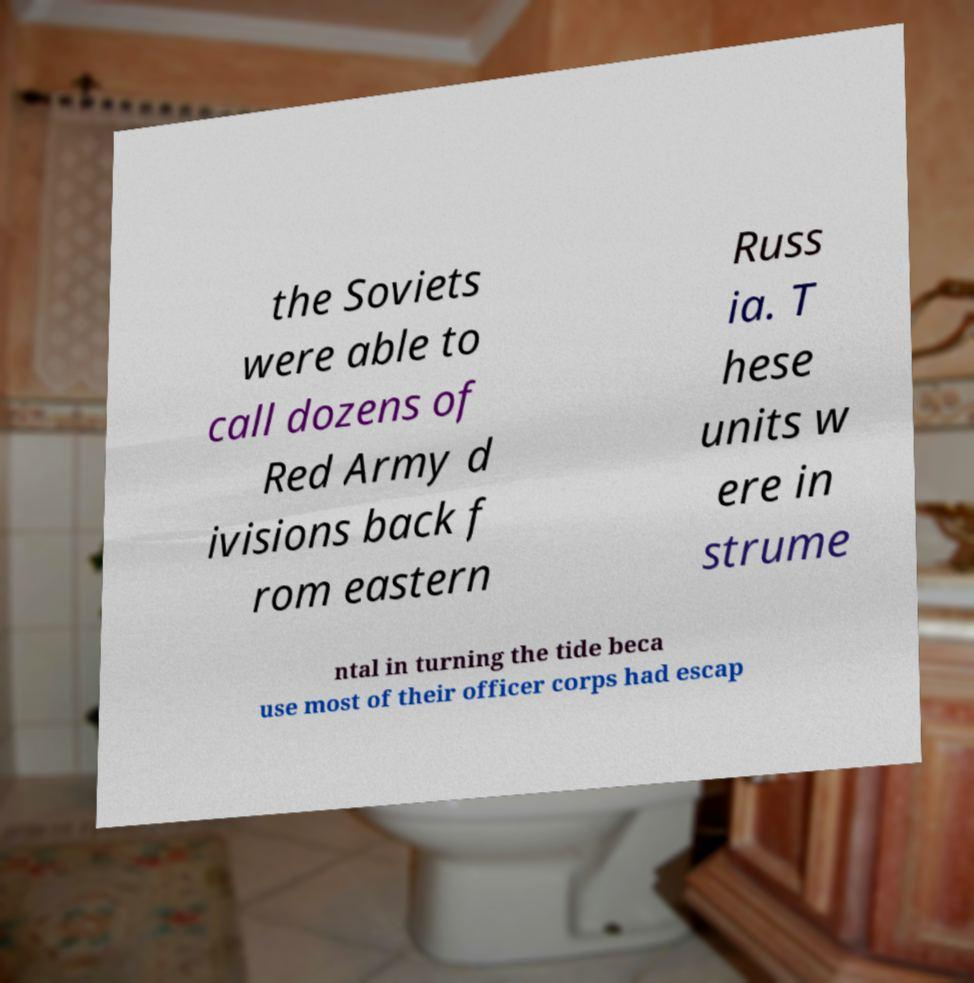Could you assist in decoding the text presented in this image and type it out clearly? the Soviets were able to call dozens of Red Army d ivisions back f rom eastern Russ ia. T hese units w ere in strume ntal in turning the tide beca use most of their officer corps had escap 